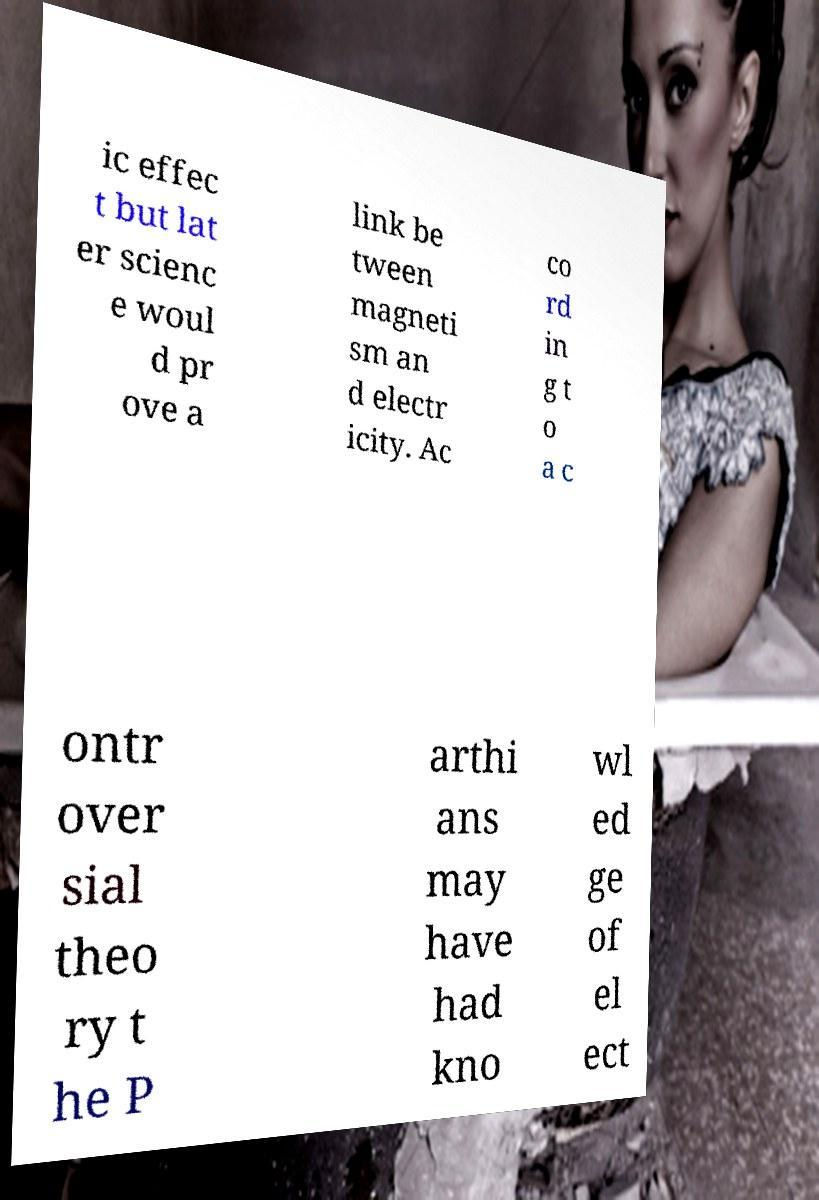Could you assist in decoding the text presented in this image and type it out clearly? ic effec t but lat er scienc e woul d pr ove a link be tween magneti sm an d electr icity. Ac co rd in g t o a c ontr over sial theo ry t he P arthi ans may have had kno wl ed ge of el ect 